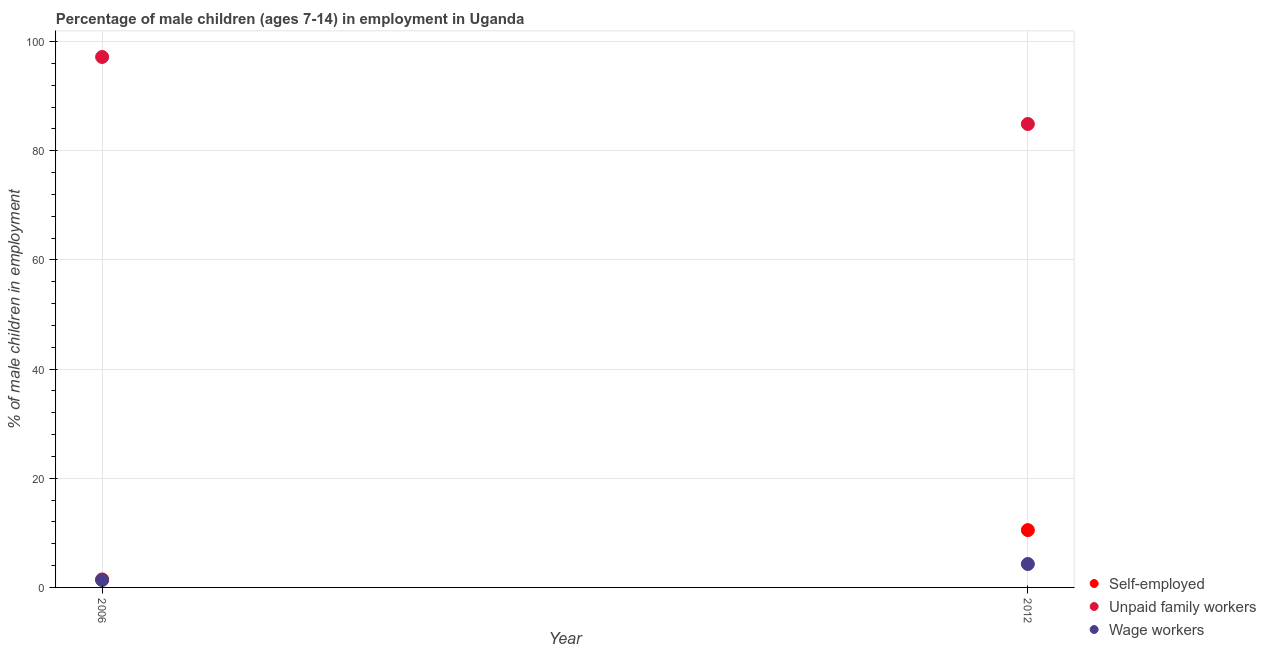What is the percentage of children employed as wage workers in 2012?
Ensure brevity in your answer.  4.29. Across all years, what is the minimum percentage of children employed as unpaid family workers?
Your answer should be compact. 84.9. What is the total percentage of self employed children in the graph?
Give a very brief answer. 11.96. What is the difference between the percentage of self employed children in 2006 and that in 2012?
Give a very brief answer. -9.04. What is the difference between the percentage of self employed children in 2006 and the percentage of children employed as wage workers in 2012?
Ensure brevity in your answer.  -2.83. What is the average percentage of self employed children per year?
Ensure brevity in your answer.  5.98. In the year 2006, what is the difference between the percentage of self employed children and percentage of children employed as unpaid family workers?
Your answer should be compact. -95.72. What is the ratio of the percentage of children employed as wage workers in 2006 to that in 2012?
Give a very brief answer. 0.32. Is the percentage of children employed as wage workers in 2006 less than that in 2012?
Ensure brevity in your answer.  Yes. In how many years, is the percentage of children employed as wage workers greater than the average percentage of children employed as wage workers taken over all years?
Your answer should be compact. 1. Is it the case that in every year, the sum of the percentage of self employed children and percentage of children employed as unpaid family workers is greater than the percentage of children employed as wage workers?
Provide a short and direct response. Yes. Does the percentage of self employed children monotonically increase over the years?
Offer a very short reply. Yes. How many years are there in the graph?
Offer a very short reply. 2. Are the values on the major ticks of Y-axis written in scientific E-notation?
Your response must be concise. No. How many legend labels are there?
Give a very brief answer. 3. What is the title of the graph?
Provide a succinct answer. Percentage of male children (ages 7-14) in employment in Uganda. What is the label or title of the Y-axis?
Keep it short and to the point. % of male children in employment. What is the % of male children in employment in Self-employed in 2006?
Your answer should be very brief. 1.46. What is the % of male children in employment in Unpaid family workers in 2006?
Your response must be concise. 97.18. What is the % of male children in employment in Wage workers in 2006?
Provide a short and direct response. 1.36. What is the % of male children in employment of Unpaid family workers in 2012?
Keep it short and to the point. 84.9. What is the % of male children in employment in Wage workers in 2012?
Provide a succinct answer. 4.29. Across all years, what is the maximum % of male children in employment in Self-employed?
Your response must be concise. 10.5. Across all years, what is the maximum % of male children in employment of Unpaid family workers?
Offer a terse response. 97.18. Across all years, what is the maximum % of male children in employment in Wage workers?
Make the answer very short. 4.29. Across all years, what is the minimum % of male children in employment of Self-employed?
Your answer should be compact. 1.46. Across all years, what is the minimum % of male children in employment of Unpaid family workers?
Offer a very short reply. 84.9. Across all years, what is the minimum % of male children in employment of Wage workers?
Your answer should be very brief. 1.36. What is the total % of male children in employment in Self-employed in the graph?
Make the answer very short. 11.96. What is the total % of male children in employment in Unpaid family workers in the graph?
Make the answer very short. 182.08. What is the total % of male children in employment of Wage workers in the graph?
Give a very brief answer. 5.65. What is the difference between the % of male children in employment in Self-employed in 2006 and that in 2012?
Offer a terse response. -9.04. What is the difference between the % of male children in employment in Unpaid family workers in 2006 and that in 2012?
Offer a terse response. 12.28. What is the difference between the % of male children in employment of Wage workers in 2006 and that in 2012?
Keep it short and to the point. -2.93. What is the difference between the % of male children in employment in Self-employed in 2006 and the % of male children in employment in Unpaid family workers in 2012?
Keep it short and to the point. -83.44. What is the difference between the % of male children in employment in Self-employed in 2006 and the % of male children in employment in Wage workers in 2012?
Your answer should be compact. -2.83. What is the difference between the % of male children in employment of Unpaid family workers in 2006 and the % of male children in employment of Wage workers in 2012?
Your answer should be very brief. 92.89. What is the average % of male children in employment of Self-employed per year?
Your answer should be compact. 5.98. What is the average % of male children in employment in Unpaid family workers per year?
Make the answer very short. 91.04. What is the average % of male children in employment in Wage workers per year?
Your answer should be very brief. 2.83. In the year 2006, what is the difference between the % of male children in employment of Self-employed and % of male children in employment of Unpaid family workers?
Provide a short and direct response. -95.72. In the year 2006, what is the difference between the % of male children in employment in Unpaid family workers and % of male children in employment in Wage workers?
Your answer should be compact. 95.82. In the year 2012, what is the difference between the % of male children in employment in Self-employed and % of male children in employment in Unpaid family workers?
Give a very brief answer. -74.4. In the year 2012, what is the difference between the % of male children in employment of Self-employed and % of male children in employment of Wage workers?
Your response must be concise. 6.21. In the year 2012, what is the difference between the % of male children in employment in Unpaid family workers and % of male children in employment in Wage workers?
Offer a very short reply. 80.61. What is the ratio of the % of male children in employment of Self-employed in 2006 to that in 2012?
Provide a short and direct response. 0.14. What is the ratio of the % of male children in employment of Unpaid family workers in 2006 to that in 2012?
Make the answer very short. 1.14. What is the ratio of the % of male children in employment of Wage workers in 2006 to that in 2012?
Your answer should be compact. 0.32. What is the difference between the highest and the second highest % of male children in employment in Self-employed?
Ensure brevity in your answer.  9.04. What is the difference between the highest and the second highest % of male children in employment of Unpaid family workers?
Provide a succinct answer. 12.28. What is the difference between the highest and the second highest % of male children in employment of Wage workers?
Provide a succinct answer. 2.93. What is the difference between the highest and the lowest % of male children in employment of Self-employed?
Provide a short and direct response. 9.04. What is the difference between the highest and the lowest % of male children in employment in Unpaid family workers?
Provide a short and direct response. 12.28. What is the difference between the highest and the lowest % of male children in employment of Wage workers?
Give a very brief answer. 2.93. 